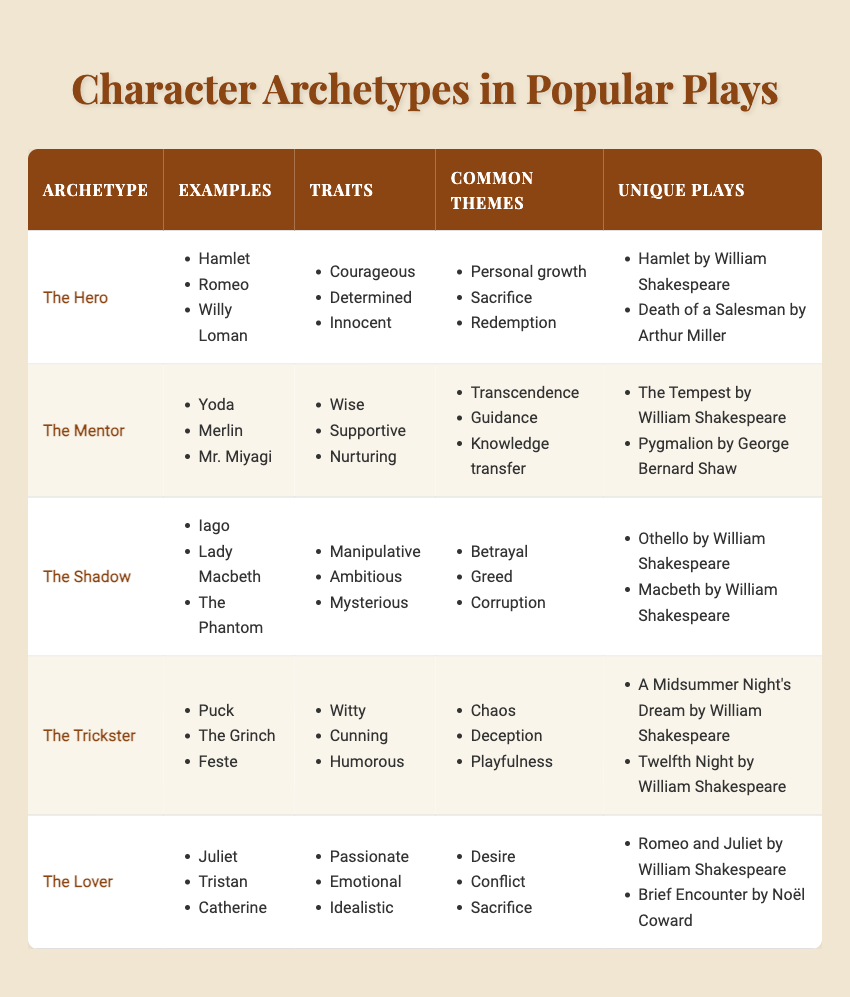What character archetype is associated with the theme of personal growth? The table shows that "The Hero" archetype has "Personal growth" as one of its common themes. Therefore, the archetype related to this theme is "The Hero."
Answer: The Hero How many unique plays feature "The Shadow" archetype? By observing the table, "The Shadow" archetype is listed with two unique plays: "Othello by William Shakespeare" and "Macbeth by William Shakespeare." Therefore, there are 2 unique plays.
Answer: 2 Which archetype is characterized by traits such as being witty and humorous? From the table, "The Trickster" is defined by traits such as "Witty" and "Humorous," which indicates that these traits belong to this specific archetype.
Answer: The Trickster Does "The Mentor" archetype include examples from works by William Shakespeare? The table lists examples for "The Mentor," which includes "Yoda," "Merlin," and "Mr. Miyagi." The unique plays for this archetype are "The Tempest by William Shakespeare" and "Pygmalion by George Bernard Shaw," confirming that Shakespeare's plays are included.
Answer: Yes Which archetype has the highest number of traits listed in the table? By examining the traits listed for each archetype, we see that all archetypes have three traits each. Thus, it follows that no archetype has a higher count than three traits.
Answer: None What is the common theme that relates to "desire" and "conflict"? The table indicates that "The Lover" archetype has common themes, including "Desire" and "Conflict." Therefore, the common theme associated with both these terms is found in "The Lover" archetype.
Answer: The Lover Name a character example of "The Lover" archetype. Looking at the table, "The Lover" archetype includes examples such as "Juliet," "Tristan," and "Catherine," making any of these valid answers.
Answer: Juliet How many archetypes have unique plays written by Arthur Miller? By examining the unique plays of the listed archetypes, only "The Hero" archetype includes a unique play by Arthur Miller, specifically "Death of a Salesman." Therefore, there is one archetype with unique plays written by Arthur Miller.
Answer: 1 Which archetype includes themes related to betrayal and greed? The table shows that "The Shadow" archetype is linked with the themes of "Betrayal" and "Greed," meaning that these themes are associated with "The Shadow."
Answer: The Shadow 